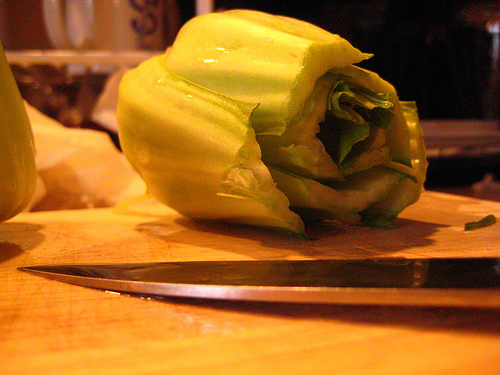<image>
Is the vegetable next to the knife? Yes. The vegetable is positioned adjacent to the knife, located nearby in the same general area. 